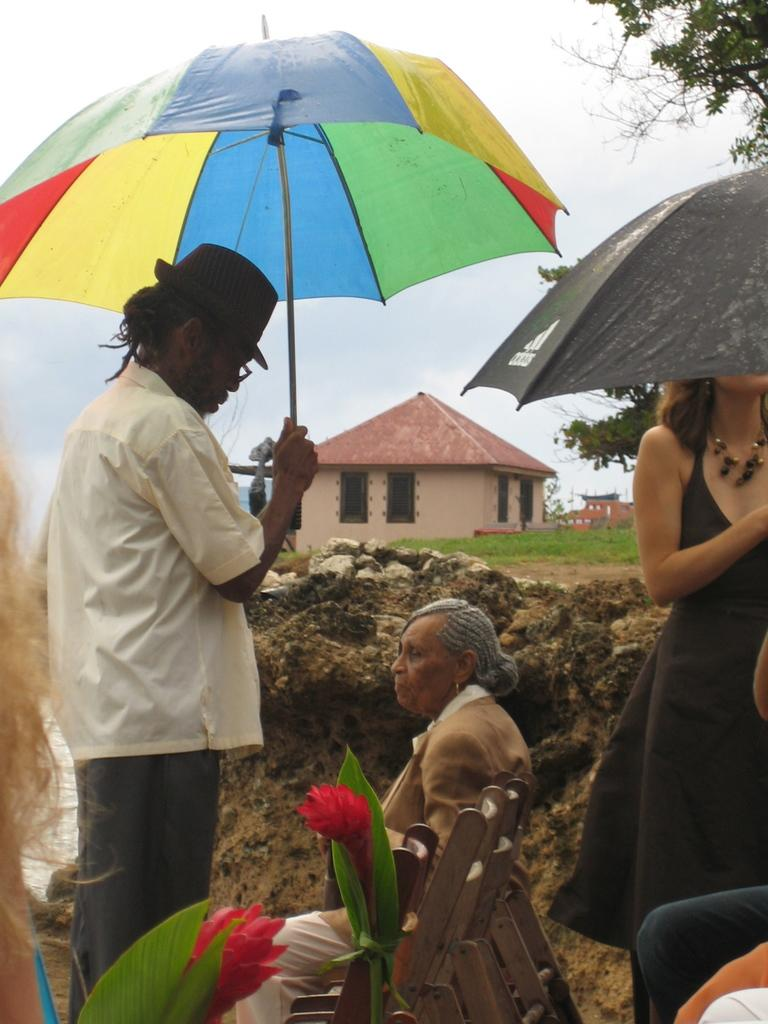What is the person in the image doing? There is a person sitting on a bench in the image. What are the two people holding in the image? The two people are holding umbrellas in the image. What type of structure can be seen in the image? There is a hut in the image. What type of plants are visible in the image? There are two flowers in the image. What type of cast is the person wearing in the image? There is no cast visible on the person in the image. What is the grandmother doing in the image? There is no grandmother present in the image. What is the bucket used for in the image? There is no bucket present in the image. 